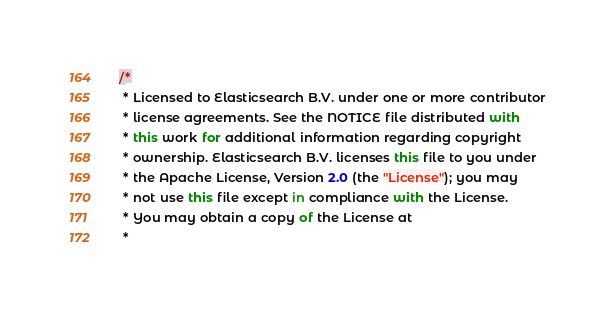<code> <loc_0><loc_0><loc_500><loc_500><_JavaScript_>/*
 * Licensed to Elasticsearch B.V. under one or more contributor
 * license agreements. See the NOTICE file distributed with
 * this work for additional information regarding copyright
 * ownership. Elasticsearch B.V. licenses this file to you under
 * the Apache License, Version 2.0 (the "License"); you may
 * not use this file except in compliance with the License.
 * You may obtain a copy of the License at
 *</code> 